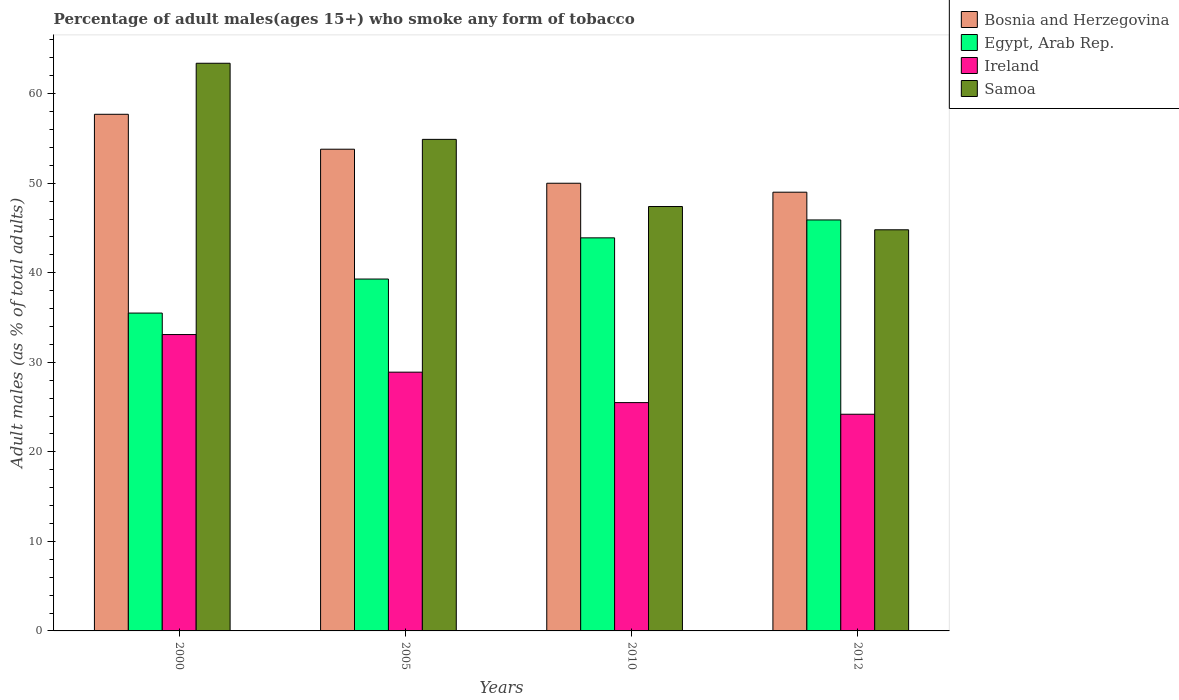How many different coloured bars are there?
Offer a very short reply. 4. How many groups of bars are there?
Ensure brevity in your answer.  4. What is the label of the 3rd group of bars from the left?
Your answer should be very brief. 2010. What is the percentage of adult males who smoke in Ireland in 2012?
Provide a succinct answer. 24.2. Across all years, what is the maximum percentage of adult males who smoke in Samoa?
Keep it short and to the point. 63.4. Across all years, what is the minimum percentage of adult males who smoke in Ireland?
Your answer should be compact. 24.2. In which year was the percentage of adult males who smoke in Bosnia and Herzegovina maximum?
Your answer should be compact. 2000. In which year was the percentage of adult males who smoke in Egypt, Arab Rep. minimum?
Offer a terse response. 2000. What is the total percentage of adult males who smoke in Ireland in the graph?
Give a very brief answer. 111.7. What is the difference between the percentage of adult males who smoke in Samoa in 2005 and that in 2010?
Your answer should be compact. 7.5. What is the difference between the percentage of adult males who smoke in Ireland in 2000 and the percentage of adult males who smoke in Bosnia and Herzegovina in 2012?
Your answer should be compact. -15.9. What is the average percentage of adult males who smoke in Ireland per year?
Offer a terse response. 27.93. In the year 2005, what is the difference between the percentage of adult males who smoke in Samoa and percentage of adult males who smoke in Egypt, Arab Rep.?
Provide a succinct answer. 15.6. What is the ratio of the percentage of adult males who smoke in Bosnia and Herzegovina in 2005 to that in 2010?
Ensure brevity in your answer.  1.08. What is the difference between the highest and the second highest percentage of adult males who smoke in Egypt, Arab Rep.?
Make the answer very short. 2. What is the difference between the highest and the lowest percentage of adult males who smoke in Bosnia and Herzegovina?
Provide a succinct answer. 8.7. What does the 2nd bar from the left in 2005 represents?
Give a very brief answer. Egypt, Arab Rep. What does the 4th bar from the right in 2005 represents?
Make the answer very short. Bosnia and Herzegovina. How many bars are there?
Ensure brevity in your answer.  16. How many years are there in the graph?
Ensure brevity in your answer.  4. What is the difference between two consecutive major ticks on the Y-axis?
Make the answer very short. 10. Does the graph contain any zero values?
Provide a succinct answer. No. Does the graph contain grids?
Your response must be concise. No. Where does the legend appear in the graph?
Your answer should be compact. Top right. How are the legend labels stacked?
Your response must be concise. Vertical. What is the title of the graph?
Provide a succinct answer. Percentage of adult males(ages 15+) who smoke any form of tobacco. What is the label or title of the X-axis?
Your answer should be compact. Years. What is the label or title of the Y-axis?
Your answer should be very brief. Adult males (as % of total adults). What is the Adult males (as % of total adults) in Bosnia and Herzegovina in 2000?
Provide a succinct answer. 57.7. What is the Adult males (as % of total adults) of Egypt, Arab Rep. in 2000?
Your answer should be compact. 35.5. What is the Adult males (as % of total adults) in Ireland in 2000?
Make the answer very short. 33.1. What is the Adult males (as % of total adults) of Samoa in 2000?
Your answer should be compact. 63.4. What is the Adult males (as % of total adults) in Bosnia and Herzegovina in 2005?
Your response must be concise. 53.8. What is the Adult males (as % of total adults) of Egypt, Arab Rep. in 2005?
Provide a succinct answer. 39.3. What is the Adult males (as % of total adults) of Ireland in 2005?
Offer a very short reply. 28.9. What is the Adult males (as % of total adults) in Samoa in 2005?
Provide a short and direct response. 54.9. What is the Adult males (as % of total adults) of Egypt, Arab Rep. in 2010?
Give a very brief answer. 43.9. What is the Adult males (as % of total adults) in Ireland in 2010?
Provide a short and direct response. 25.5. What is the Adult males (as % of total adults) of Samoa in 2010?
Offer a terse response. 47.4. What is the Adult males (as % of total adults) of Egypt, Arab Rep. in 2012?
Give a very brief answer. 45.9. What is the Adult males (as % of total adults) in Ireland in 2012?
Your answer should be very brief. 24.2. What is the Adult males (as % of total adults) of Samoa in 2012?
Your response must be concise. 44.8. Across all years, what is the maximum Adult males (as % of total adults) in Bosnia and Herzegovina?
Your answer should be very brief. 57.7. Across all years, what is the maximum Adult males (as % of total adults) of Egypt, Arab Rep.?
Offer a very short reply. 45.9. Across all years, what is the maximum Adult males (as % of total adults) of Ireland?
Your response must be concise. 33.1. Across all years, what is the maximum Adult males (as % of total adults) in Samoa?
Provide a short and direct response. 63.4. Across all years, what is the minimum Adult males (as % of total adults) in Egypt, Arab Rep.?
Provide a succinct answer. 35.5. Across all years, what is the minimum Adult males (as % of total adults) in Ireland?
Provide a short and direct response. 24.2. Across all years, what is the minimum Adult males (as % of total adults) of Samoa?
Provide a short and direct response. 44.8. What is the total Adult males (as % of total adults) of Bosnia and Herzegovina in the graph?
Provide a succinct answer. 210.5. What is the total Adult males (as % of total adults) of Egypt, Arab Rep. in the graph?
Your answer should be compact. 164.6. What is the total Adult males (as % of total adults) in Ireland in the graph?
Give a very brief answer. 111.7. What is the total Adult males (as % of total adults) in Samoa in the graph?
Offer a very short reply. 210.5. What is the difference between the Adult males (as % of total adults) in Egypt, Arab Rep. in 2000 and that in 2005?
Provide a short and direct response. -3.8. What is the difference between the Adult males (as % of total adults) of Ireland in 2000 and that in 2005?
Provide a succinct answer. 4.2. What is the difference between the Adult males (as % of total adults) of Samoa in 2000 and that in 2005?
Make the answer very short. 8.5. What is the difference between the Adult males (as % of total adults) in Bosnia and Herzegovina in 2000 and that in 2010?
Your answer should be compact. 7.7. What is the difference between the Adult males (as % of total adults) of Ireland in 2000 and that in 2010?
Keep it short and to the point. 7.6. What is the difference between the Adult males (as % of total adults) in Samoa in 2000 and that in 2012?
Your answer should be compact. 18.6. What is the difference between the Adult males (as % of total adults) in Samoa in 2005 and that in 2010?
Offer a terse response. 7.5. What is the difference between the Adult males (as % of total adults) in Ireland in 2005 and that in 2012?
Ensure brevity in your answer.  4.7. What is the difference between the Adult males (as % of total adults) in Ireland in 2010 and that in 2012?
Provide a succinct answer. 1.3. What is the difference between the Adult males (as % of total adults) of Bosnia and Herzegovina in 2000 and the Adult males (as % of total adults) of Ireland in 2005?
Offer a terse response. 28.8. What is the difference between the Adult males (as % of total adults) of Egypt, Arab Rep. in 2000 and the Adult males (as % of total adults) of Ireland in 2005?
Your answer should be very brief. 6.6. What is the difference between the Adult males (as % of total adults) of Egypt, Arab Rep. in 2000 and the Adult males (as % of total adults) of Samoa in 2005?
Offer a terse response. -19.4. What is the difference between the Adult males (as % of total adults) in Ireland in 2000 and the Adult males (as % of total adults) in Samoa in 2005?
Your answer should be compact. -21.8. What is the difference between the Adult males (as % of total adults) of Bosnia and Herzegovina in 2000 and the Adult males (as % of total adults) of Egypt, Arab Rep. in 2010?
Give a very brief answer. 13.8. What is the difference between the Adult males (as % of total adults) in Bosnia and Herzegovina in 2000 and the Adult males (as % of total adults) in Ireland in 2010?
Keep it short and to the point. 32.2. What is the difference between the Adult males (as % of total adults) of Egypt, Arab Rep. in 2000 and the Adult males (as % of total adults) of Ireland in 2010?
Provide a succinct answer. 10. What is the difference between the Adult males (as % of total adults) in Egypt, Arab Rep. in 2000 and the Adult males (as % of total adults) in Samoa in 2010?
Your response must be concise. -11.9. What is the difference between the Adult males (as % of total adults) of Ireland in 2000 and the Adult males (as % of total adults) of Samoa in 2010?
Keep it short and to the point. -14.3. What is the difference between the Adult males (as % of total adults) in Bosnia and Herzegovina in 2000 and the Adult males (as % of total adults) in Egypt, Arab Rep. in 2012?
Offer a terse response. 11.8. What is the difference between the Adult males (as % of total adults) in Bosnia and Herzegovina in 2000 and the Adult males (as % of total adults) in Ireland in 2012?
Your answer should be very brief. 33.5. What is the difference between the Adult males (as % of total adults) of Egypt, Arab Rep. in 2000 and the Adult males (as % of total adults) of Ireland in 2012?
Offer a terse response. 11.3. What is the difference between the Adult males (as % of total adults) in Ireland in 2000 and the Adult males (as % of total adults) in Samoa in 2012?
Provide a succinct answer. -11.7. What is the difference between the Adult males (as % of total adults) of Bosnia and Herzegovina in 2005 and the Adult males (as % of total adults) of Ireland in 2010?
Give a very brief answer. 28.3. What is the difference between the Adult males (as % of total adults) in Bosnia and Herzegovina in 2005 and the Adult males (as % of total adults) in Samoa in 2010?
Offer a very short reply. 6.4. What is the difference between the Adult males (as % of total adults) of Egypt, Arab Rep. in 2005 and the Adult males (as % of total adults) of Ireland in 2010?
Offer a terse response. 13.8. What is the difference between the Adult males (as % of total adults) in Egypt, Arab Rep. in 2005 and the Adult males (as % of total adults) in Samoa in 2010?
Provide a short and direct response. -8.1. What is the difference between the Adult males (as % of total adults) of Ireland in 2005 and the Adult males (as % of total adults) of Samoa in 2010?
Offer a very short reply. -18.5. What is the difference between the Adult males (as % of total adults) of Bosnia and Herzegovina in 2005 and the Adult males (as % of total adults) of Egypt, Arab Rep. in 2012?
Ensure brevity in your answer.  7.9. What is the difference between the Adult males (as % of total adults) in Bosnia and Herzegovina in 2005 and the Adult males (as % of total adults) in Ireland in 2012?
Make the answer very short. 29.6. What is the difference between the Adult males (as % of total adults) of Egypt, Arab Rep. in 2005 and the Adult males (as % of total adults) of Ireland in 2012?
Provide a succinct answer. 15.1. What is the difference between the Adult males (as % of total adults) of Egypt, Arab Rep. in 2005 and the Adult males (as % of total adults) of Samoa in 2012?
Keep it short and to the point. -5.5. What is the difference between the Adult males (as % of total adults) of Ireland in 2005 and the Adult males (as % of total adults) of Samoa in 2012?
Provide a short and direct response. -15.9. What is the difference between the Adult males (as % of total adults) of Bosnia and Herzegovina in 2010 and the Adult males (as % of total adults) of Ireland in 2012?
Your answer should be compact. 25.8. What is the difference between the Adult males (as % of total adults) of Egypt, Arab Rep. in 2010 and the Adult males (as % of total adults) of Ireland in 2012?
Your answer should be compact. 19.7. What is the difference between the Adult males (as % of total adults) in Ireland in 2010 and the Adult males (as % of total adults) in Samoa in 2012?
Your response must be concise. -19.3. What is the average Adult males (as % of total adults) of Bosnia and Herzegovina per year?
Your response must be concise. 52.62. What is the average Adult males (as % of total adults) in Egypt, Arab Rep. per year?
Offer a very short reply. 41.15. What is the average Adult males (as % of total adults) in Ireland per year?
Offer a terse response. 27.93. What is the average Adult males (as % of total adults) in Samoa per year?
Ensure brevity in your answer.  52.62. In the year 2000, what is the difference between the Adult males (as % of total adults) of Bosnia and Herzegovina and Adult males (as % of total adults) of Ireland?
Your answer should be very brief. 24.6. In the year 2000, what is the difference between the Adult males (as % of total adults) in Egypt, Arab Rep. and Adult males (as % of total adults) in Samoa?
Provide a short and direct response. -27.9. In the year 2000, what is the difference between the Adult males (as % of total adults) in Ireland and Adult males (as % of total adults) in Samoa?
Keep it short and to the point. -30.3. In the year 2005, what is the difference between the Adult males (as % of total adults) in Bosnia and Herzegovina and Adult males (as % of total adults) in Egypt, Arab Rep.?
Your response must be concise. 14.5. In the year 2005, what is the difference between the Adult males (as % of total adults) in Bosnia and Herzegovina and Adult males (as % of total adults) in Ireland?
Your answer should be very brief. 24.9. In the year 2005, what is the difference between the Adult males (as % of total adults) of Egypt, Arab Rep. and Adult males (as % of total adults) of Ireland?
Ensure brevity in your answer.  10.4. In the year 2005, what is the difference between the Adult males (as % of total adults) in Egypt, Arab Rep. and Adult males (as % of total adults) in Samoa?
Provide a succinct answer. -15.6. In the year 2005, what is the difference between the Adult males (as % of total adults) in Ireland and Adult males (as % of total adults) in Samoa?
Offer a very short reply. -26. In the year 2010, what is the difference between the Adult males (as % of total adults) of Bosnia and Herzegovina and Adult males (as % of total adults) of Egypt, Arab Rep.?
Your answer should be compact. 6.1. In the year 2010, what is the difference between the Adult males (as % of total adults) of Egypt, Arab Rep. and Adult males (as % of total adults) of Samoa?
Keep it short and to the point. -3.5. In the year 2010, what is the difference between the Adult males (as % of total adults) of Ireland and Adult males (as % of total adults) of Samoa?
Your answer should be compact. -21.9. In the year 2012, what is the difference between the Adult males (as % of total adults) of Bosnia and Herzegovina and Adult males (as % of total adults) of Egypt, Arab Rep.?
Your answer should be very brief. 3.1. In the year 2012, what is the difference between the Adult males (as % of total adults) of Bosnia and Herzegovina and Adult males (as % of total adults) of Ireland?
Make the answer very short. 24.8. In the year 2012, what is the difference between the Adult males (as % of total adults) in Bosnia and Herzegovina and Adult males (as % of total adults) in Samoa?
Provide a short and direct response. 4.2. In the year 2012, what is the difference between the Adult males (as % of total adults) of Egypt, Arab Rep. and Adult males (as % of total adults) of Ireland?
Your answer should be compact. 21.7. In the year 2012, what is the difference between the Adult males (as % of total adults) of Egypt, Arab Rep. and Adult males (as % of total adults) of Samoa?
Your answer should be very brief. 1.1. In the year 2012, what is the difference between the Adult males (as % of total adults) in Ireland and Adult males (as % of total adults) in Samoa?
Provide a succinct answer. -20.6. What is the ratio of the Adult males (as % of total adults) in Bosnia and Herzegovina in 2000 to that in 2005?
Provide a succinct answer. 1.07. What is the ratio of the Adult males (as % of total adults) of Egypt, Arab Rep. in 2000 to that in 2005?
Keep it short and to the point. 0.9. What is the ratio of the Adult males (as % of total adults) of Ireland in 2000 to that in 2005?
Provide a short and direct response. 1.15. What is the ratio of the Adult males (as % of total adults) in Samoa in 2000 to that in 2005?
Keep it short and to the point. 1.15. What is the ratio of the Adult males (as % of total adults) of Bosnia and Herzegovina in 2000 to that in 2010?
Ensure brevity in your answer.  1.15. What is the ratio of the Adult males (as % of total adults) of Egypt, Arab Rep. in 2000 to that in 2010?
Offer a terse response. 0.81. What is the ratio of the Adult males (as % of total adults) of Ireland in 2000 to that in 2010?
Keep it short and to the point. 1.3. What is the ratio of the Adult males (as % of total adults) in Samoa in 2000 to that in 2010?
Keep it short and to the point. 1.34. What is the ratio of the Adult males (as % of total adults) in Bosnia and Herzegovina in 2000 to that in 2012?
Give a very brief answer. 1.18. What is the ratio of the Adult males (as % of total adults) in Egypt, Arab Rep. in 2000 to that in 2012?
Give a very brief answer. 0.77. What is the ratio of the Adult males (as % of total adults) of Ireland in 2000 to that in 2012?
Provide a short and direct response. 1.37. What is the ratio of the Adult males (as % of total adults) of Samoa in 2000 to that in 2012?
Provide a short and direct response. 1.42. What is the ratio of the Adult males (as % of total adults) of Bosnia and Herzegovina in 2005 to that in 2010?
Give a very brief answer. 1.08. What is the ratio of the Adult males (as % of total adults) in Egypt, Arab Rep. in 2005 to that in 2010?
Offer a very short reply. 0.9. What is the ratio of the Adult males (as % of total adults) in Ireland in 2005 to that in 2010?
Your answer should be very brief. 1.13. What is the ratio of the Adult males (as % of total adults) of Samoa in 2005 to that in 2010?
Your answer should be compact. 1.16. What is the ratio of the Adult males (as % of total adults) of Bosnia and Herzegovina in 2005 to that in 2012?
Offer a very short reply. 1.1. What is the ratio of the Adult males (as % of total adults) in Egypt, Arab Rep. in 2005 to that in 2012?
Provide a short and direct response. 0.86. What is the ratio of the Adult males (as % of total adults) in Ireland in 2005 to that in 2012?
Provide a succinct answer. 1.19. What is the ratio of the Adult males (as % of total adults) of Samoa in 2005 to that in 2012?
Your response must be concise. 1.23. What is the ratio of the Adult males (as % of total adults) of Bosnia and Herzegovina in 2010 to that in 2012?
Your answer should be very brief. 1.02. What is the ratio of the Adult males (as % of total adults) of Egypt, Arab Rep. in 2010 to that in 2012?
Ensure brevity in your answer.  0.96. What is the ratio of the Adult males (as % of total adults) in Ireland in 2010 to that in 2012?
Ensure brevity in your answer.  1.05. What is the ratio of the Adult males (as % of total adults) in Samoa in 2010 to that in 2012?
Offer a very short reply. 1.06. What is the difference between the highest and the second highest Adult males (as % of total adults) in Egypt, Arab Rep.?
Keep it short and to the point. 2. What is the difference between the highest and the second highest Adult males (as % of total adults) of Ireland?
Provide a short and direct response. 4.2. What is the difference between the highest and the second highest Adult males (as % of total adults) of Samoa?
Offer a very short reply. 8.5. What is the difference between the highest and the lowest Adult males (as % of total adults) in Bosnia and Herzegovina?
Ensure brevity in your answer.  8.7. 